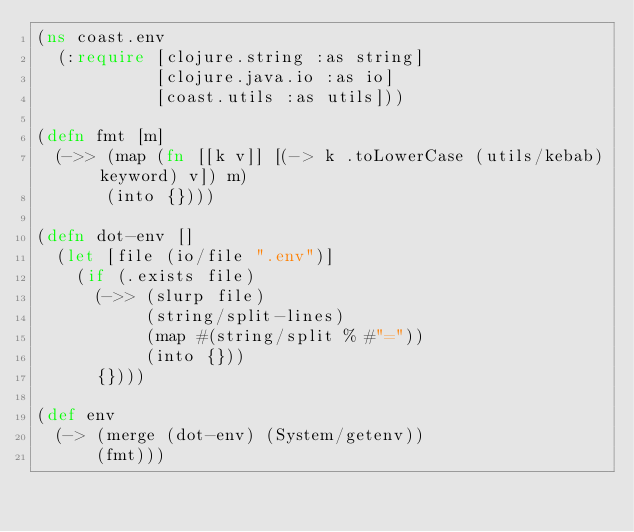Convert code to text. <code><loc_0><loc_0><loc_500><loc_500><_Clojure_>(ns coast.env
  (:require [clojure.string :as string]
            [clojure.java.io :as io]
            [coast.utils :as utils]))

(defn fmt [m]
  (->> (map (fn [[k v]] [(-> k .toLowerCase (utils/kebab) keyword) v]) m)
       (into {})))

(defn dot-env []
  (let [file (io/file ".env")]
    (if (.exists file)
      (->> (slurp file)
           (string/split-lines)
           (map #(string/split % #"="))
           (into {}))
      {})))

(def env
  (-> (merge (dot-env) (System/getenv))
      (fmt)))
</code> 